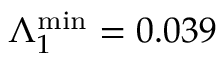Convert formula to latex. <formula><loc_0><loc_0><loc_500><loc_500>\Lambda _ { 1 } ^ { \min } = 0 . 0 3 9</formula> 